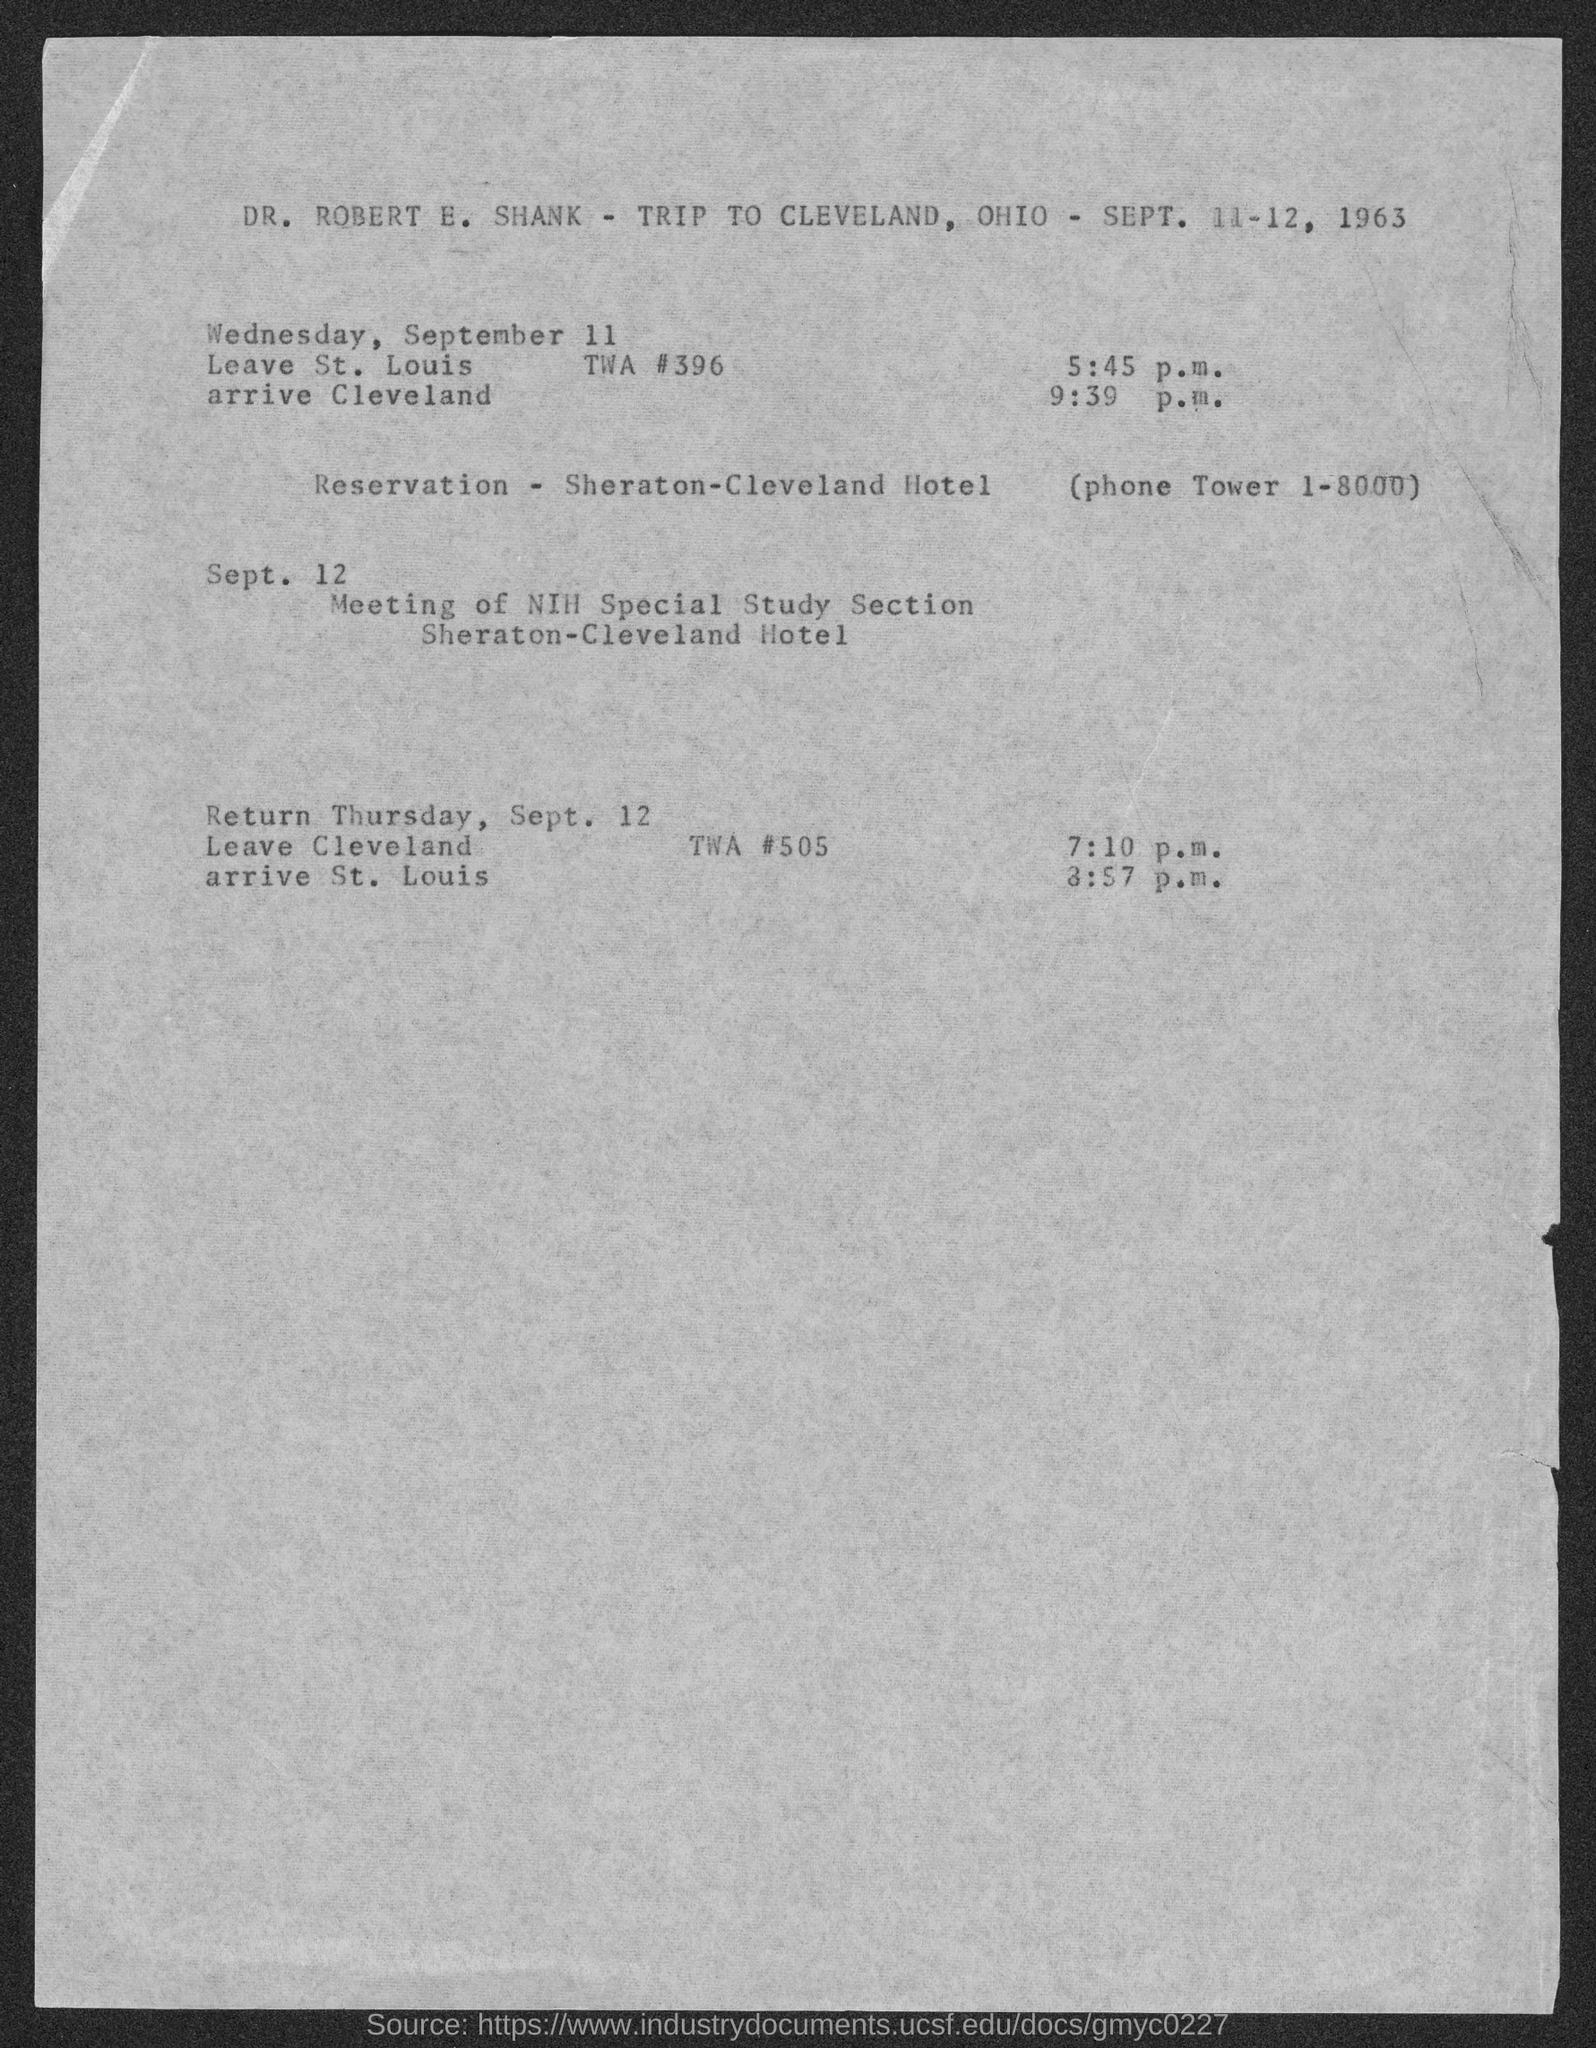Who is going on a trip to CLEVELAND,OHIO?
Provide a succinct answer. ROBERT E. SHANK. DR. ROBERT  E. SHANK is going on a trip to which place?
Make the answer very short. CLEVELAND. At what time will DR.  ROBERT E.  SHANK  reach Cleaveland?
Keep it short and to the point. 9:39  p.m. Which hotel  in Cleveland has DR. ROBERT E. SHANK done his reservation ?
Give a very brief answer. Sheraton-Cleveland Hotel   (phone Tower 1-8000). DR. ROBERT E. SHANK  is having meeting of which section on  Sept. 12?
Make the answer very short. Nih special study section. When is  DR. ROBERT E. SHANK returning from Cleveland?
Your answer should be very brief. Sept. 12. A t what time will  DR. ROBERT E. SHANK leave  Cleveland?
Your answer should be very brief. 7:10 p.m. At what  time will DR. ROBERT E. SHANK arrive at St. Louis?
Give a very brief answer. 3:57  p.m. Which year is DR. ROBERT E. SHANK planning his trip  to Cleveland?
Provide a short and direct response. 1963. What is phone Tower number?
Offer a terse response. Phone tower 1-8000. 